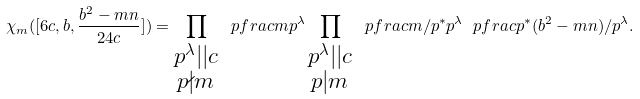Convert formula to latex. <formula><loc_0><loc_0><loc_500><loc_500>\chi _ { m } ( [ 6 c , b , \frac { b ^ { 2 } - m n } { 2 4 c } ] ) = \prod _ { \substack { p ^ { \lambda } | | c \\ p \nmid m } } \ p f r a c { m } { p ^ { \lambda } } \prod _ { \substack { p ^ { \lambda } | | c \\ p | m } } \ p f r a c { m / p ^ { * } } { p ^ { \lambda } } \ p f r a c { p ^ { * } } { ( b ^ { 2 } - m n ) / p ^ { \lambda } } .</formula> 